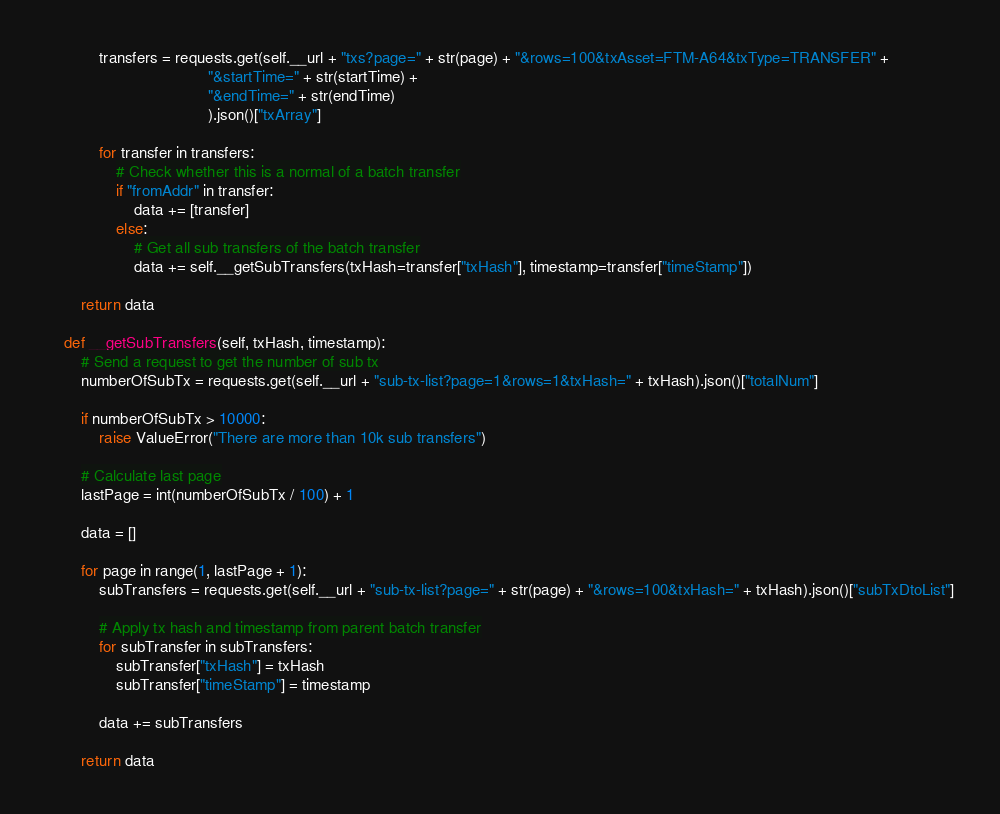<code> <loc_0><loc_0><loc_500><loc_500><_Python_>            transfers = requests.get(self.__url + "txs?page=" + str(page) + "&rows=100&txAsset=FTM-A64&txType=TRANSFER" +
                                     "&startTime=" + str(startTime) +
                                     "&endTime=" + str(endTime)
                                     ).json()["txArray"]

            for transfer in transfers:
                # Check whether this is a normal of a batch transfer
                if "fromAddr" in transfer:
                    data += [transfer]
                else:
                    # Get all sub transfers of the batch transfer
                    data += self.__getSubTransfers(txHash=transfer["txHash"], timestamp=transfer["timeStamp"])

        return data

    def __getSubTransfers(self, txHash, timestamp):
        # Send a request to get the number of sub tx
        numberOfSubTx = requests.get(self.__url + "sub-tx-list?page=1&rows=1&txHash=" + txHash).json()["totalNum"]

        if numberOfSubTx > 10000:
            raise ValueError("There are more than 10k sub transfers")

        # Calculate last page
        lastPage = int(numberOfSubTx / 100) + 1

        data = []

        for page in range(1, lastPage + 1):
            subTransfers = requests.get(self.__url + "sub-tx-list?page=" + str(page) + "&rows=100&txHash=" + txHash).json()["subTxDtoList"]

            # Apply tx hash and timestamp from parent batch transfer
            for subTransfer in subTransfers:
                subTransfer["txHash"] = txHash
                subTransfer["timeStamp"] = timestamp

            data += subTransfers

        return data
</code> 